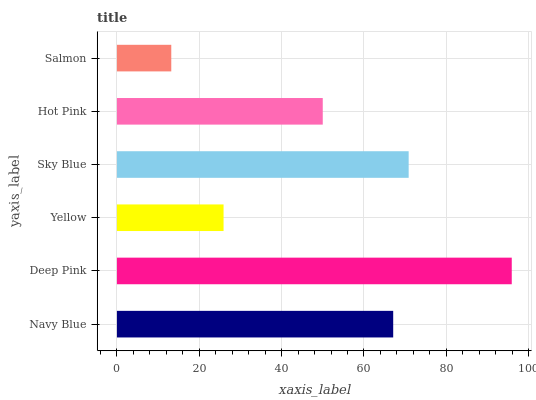Is Salmon the minimum?
Answer yes or no. Yes. Is Deep Pink the maximum?
Answer yes or no. Yes. Is Yellow the minimum?
Answer yes or no. No. Is Yellow the maximum?
Answer yes or no. No. Is Deep Pink greater than Yellow?
Answer yes or no. Yes. Is Yellow less than Deep Pink?
Answer yes or no. Yes. Is Yellow greater than Deep Pink?
Answer yes or no. No. Is Deep Pink less than Yellow?
Answer yes or no. No. Is Navy Blue the high median?
Answer yes or no. Yes. Is Hot Pink the low median?
Answer yes or no. Yes. Is Hot Pink the high median?
Answer yes or no. No. Is Yellow the low median?
Answer yes or no. No. 